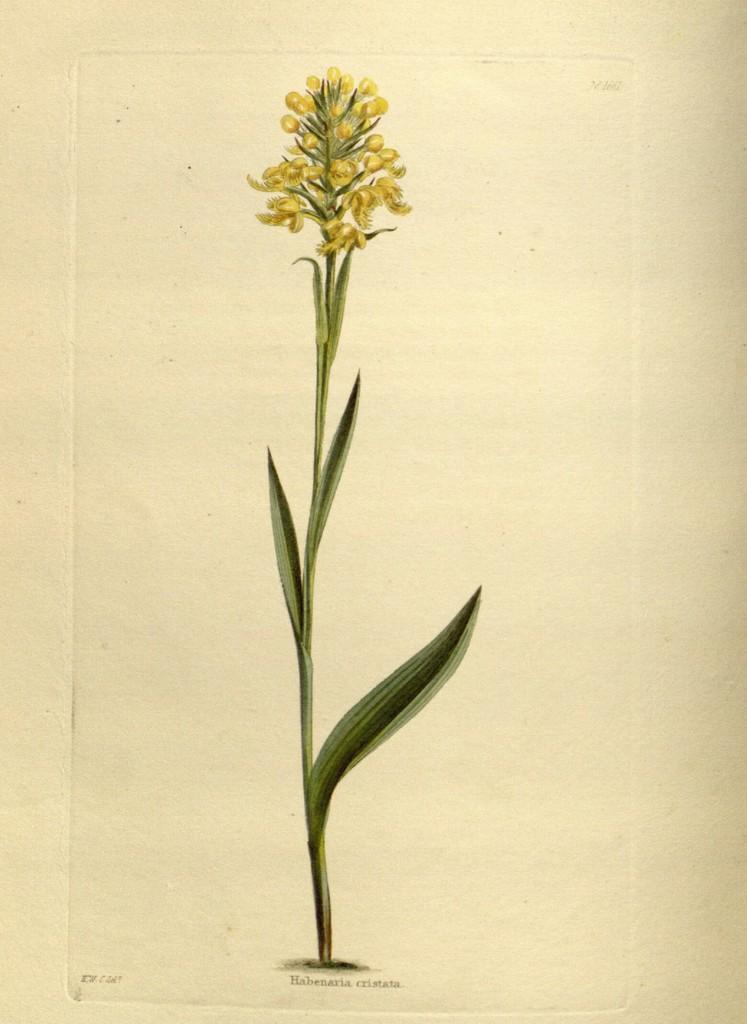Could you give a brief overview of what you see in this image? In this image we can see a poster, on the poster, we can see a plant with some flowers and buds, also we can see the text. 